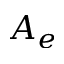<formula> <loc_0><loc_0><loc_500><loc_500>A _ { e }</formula> 